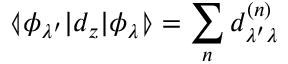<formula> <loc_0><loc_0><loc_500><loc_500>\ll a n g l e \phi _ { \lambda ^ { \prime } } | d _ { z } | \phi _ { \lambda } \ r r a n g l e = \sum _ { n } d _ { \lambda ^ { \prime } \lambda } ^ { ( n ) }</formula> 